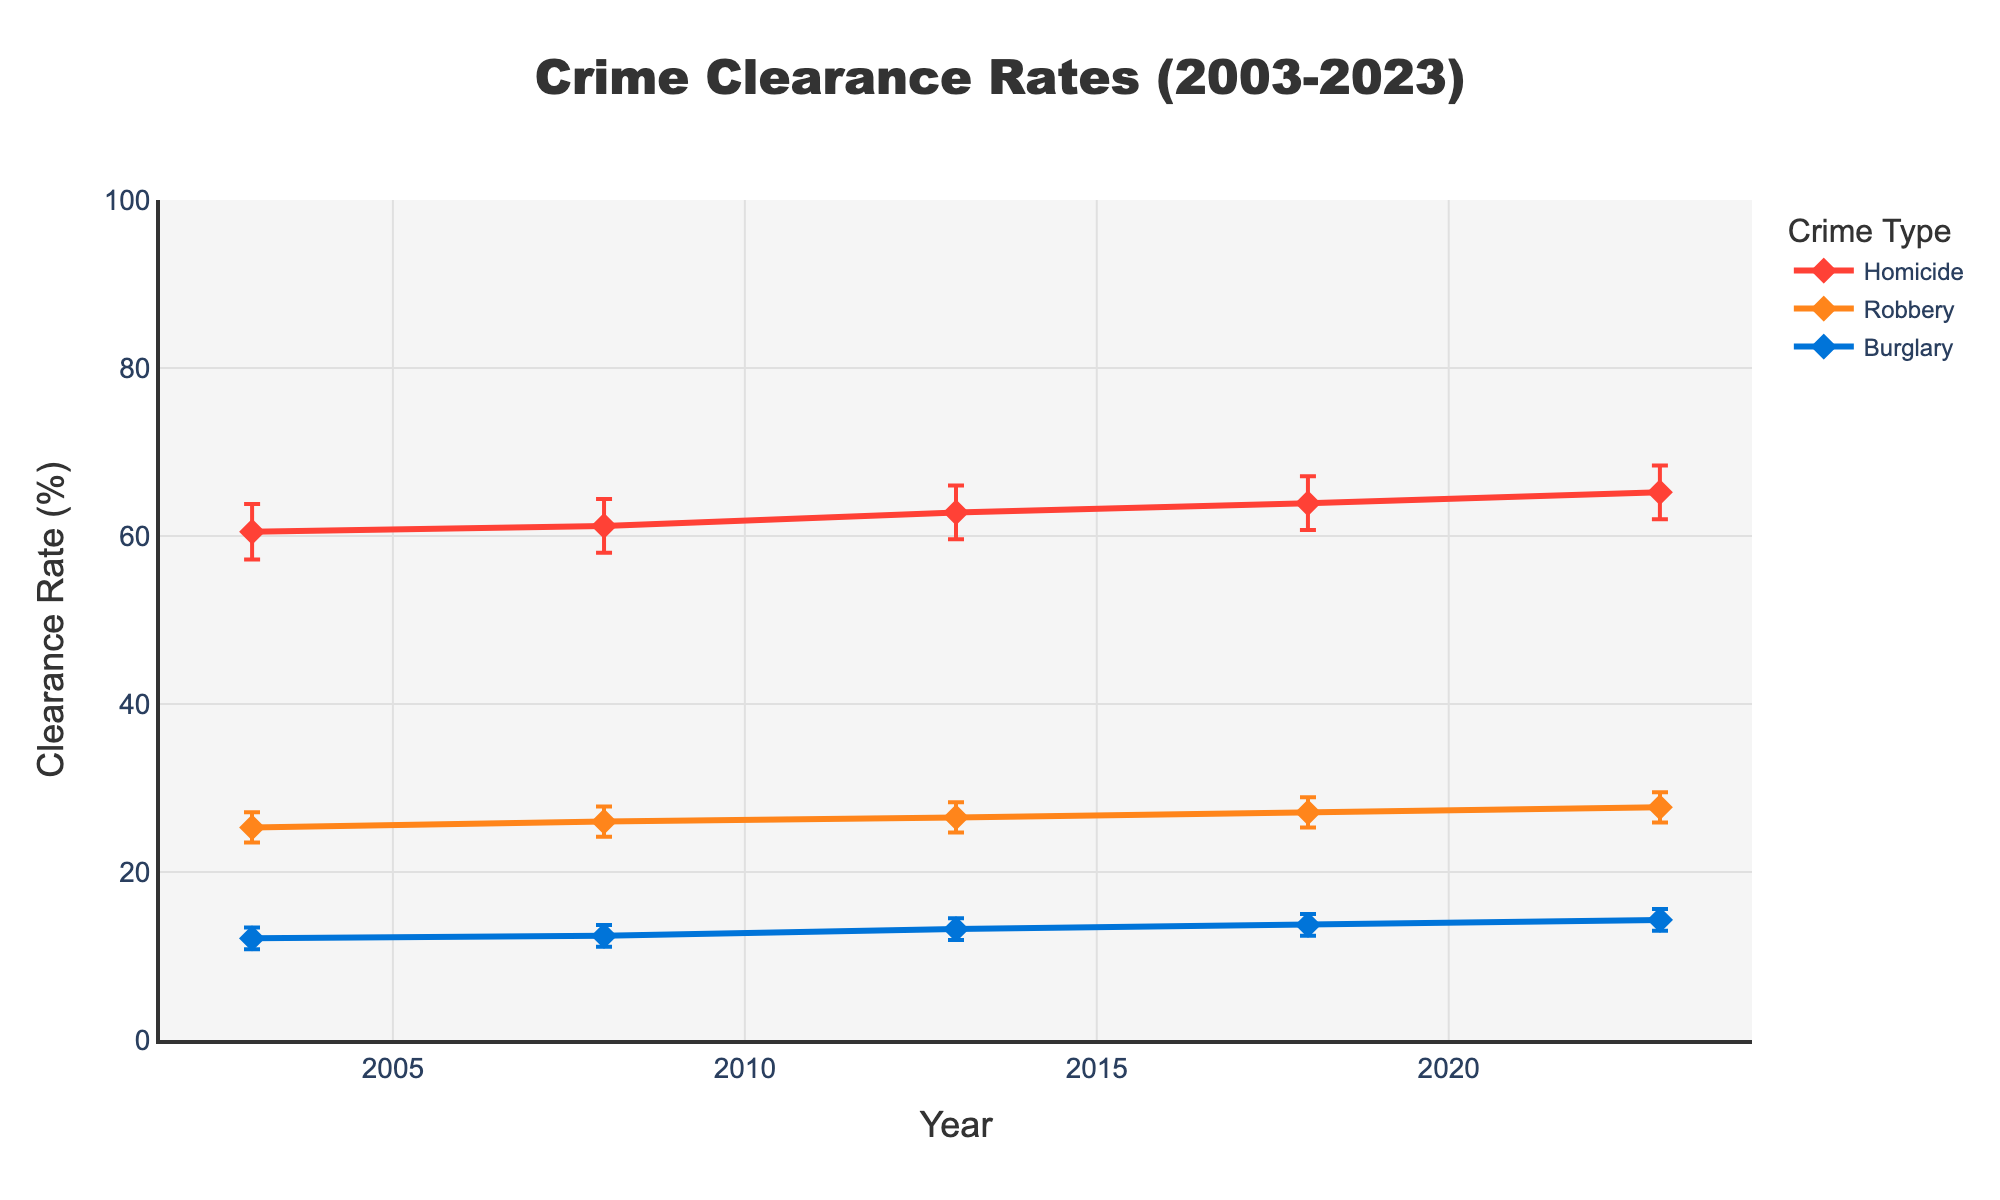What is the highest clearance rate for homicides and in which year does it occur? The highest clearance rate for homicides is found by looking at the highest point on the homicide line. The highest clearance rate in the data provided is 65.2% in the year 2023.
Answer: 65.2% in 2023 Which crime type has the lowest clearance rate in 2003? To find the lowest clearance rate in 2003, compare the clearance rates for homicide, robbery, and burglary in that year. Homicide has a clearance rate of 60.5%, robbery has 25.3%, and burglary has the lowest with 12.1%.
Answer: Burglary How has the clearance rate for robbery changed from 2003 to 2023? Examine the clearance rates for robbery in 2003 and 2023. In 2003, the clearance rate was 25.3%, and in 2023, it was 27.7%. The difference can be found by subtracting the two rates: 27.7% - 25.3% = 2.4%. This indicates an increase of 2.4%.
Answer: Increased by 2.4% Which crime type shows the most improvement in clearance rates from 2003 to 2023? Calculate the increase in clearance rates between 2003 and 2023 for each crime type. Homicide increased by (65.2 - 60.5) = 4.7%, robbery increased by (27.7 - 25.3) = 2.4%, and burglary increased by (14.3 - 12.1) = 2.2%. Homicide shows the most improvement.
Answer: Homicide What is the average clearance rate for burglary over the 20 years? Find the clearance rates for burglary for each year and calculate the average. The rates are 12.1, 12.4, 13.2, 13.7, and 14.3. Sum these up: 12.1 + 12.4 + 13.2 + 13.7 + 14.3 = 65.7. Then, average them by dividing by 5: 65.7 / 5 = 13.14.
Answer: 13.14% How consistent are the clearance rates for homicide over the years? Look at the clearance rates for homicides and compare them across years. The values are 60.5%, 61.2%, 62.8%, 63.9%, and 65.2%. The rates show a steady and gradual increase, indicating consistent improvement.
Answer: Consistent improvement What do the error bars represent in the figure? The error bars represent the confidence intervals for the clearance rates. Each bar shows the range within which the true clearance rate likely falls, with the top of the bar indicating the upper confidence interval and the bottom indicating the lower confidence interval.
Answer: Confidence intervals Are there any years where the clearance rates for robbery and burglary are similar? Compare the clearance rates for robbery and burglary in each given year to identify any similarities. In 2013, robbery has a clearance rate of 26.5% and burglary has 13.2%, which are not very similar. The closest comparison might be in 2003 where robbery has 25.3% and burglary has 12.1%, but even this shows a noticeable difference. Therefore, no years have them highly similar.
Answer: No Which year has the widest confidence interval for homicides? Look at the length of the confidence intervals represented by the error bars for homicides across all years. Compare the ranges: 2003: 63.8 - 57.2 = 6.6, 2008: 64.4 - 58.0 = 6.4, 2013: 66.0 - 59.6 = 6.4, 2018: 67.1 - 60.7 = 6.4, 2023: 68.4 - 62.0 = 6.4. The widest interval is in 2003 with a range of 6.6.
Answer: 2003 